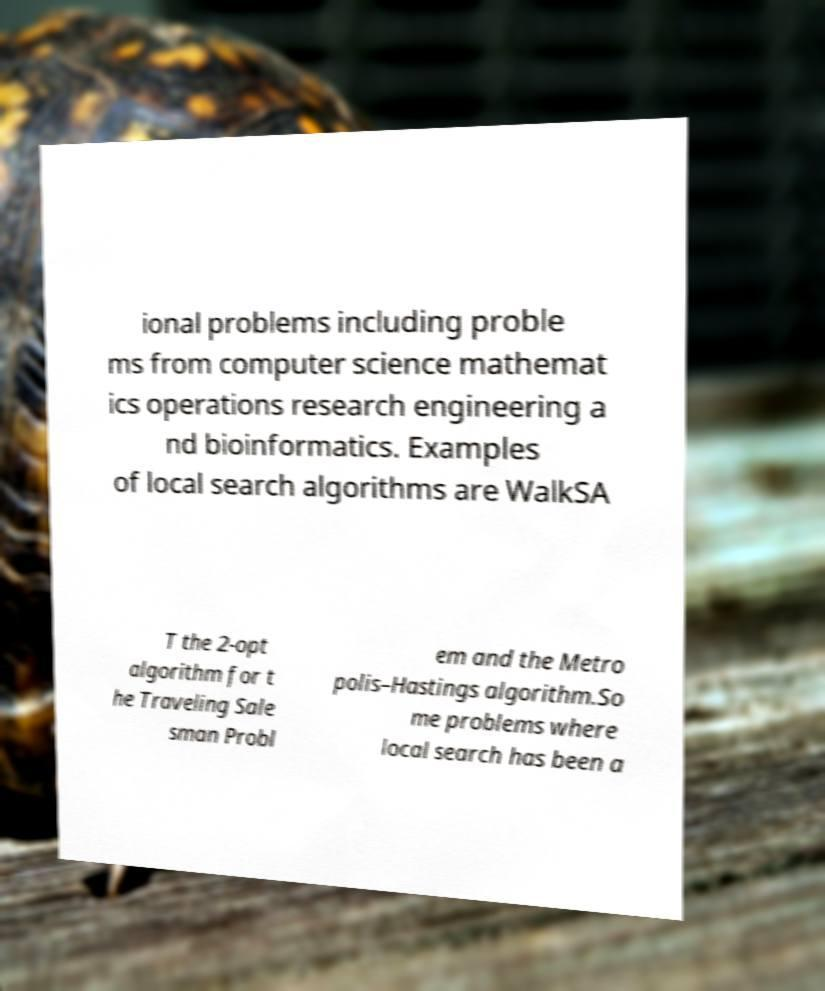Could you assist in decoding the text presented in this image and type it out clearly? ional problems including proble ms from computer science mathemat ics operations research engineering a nd bioinformatics. Examples of local search algorithms are WalkSA T the 2-opt algorithm for t he Traveling Sale sman Probl em and the Metro polis–Hastings algorithm.So me problems where local search has been a 